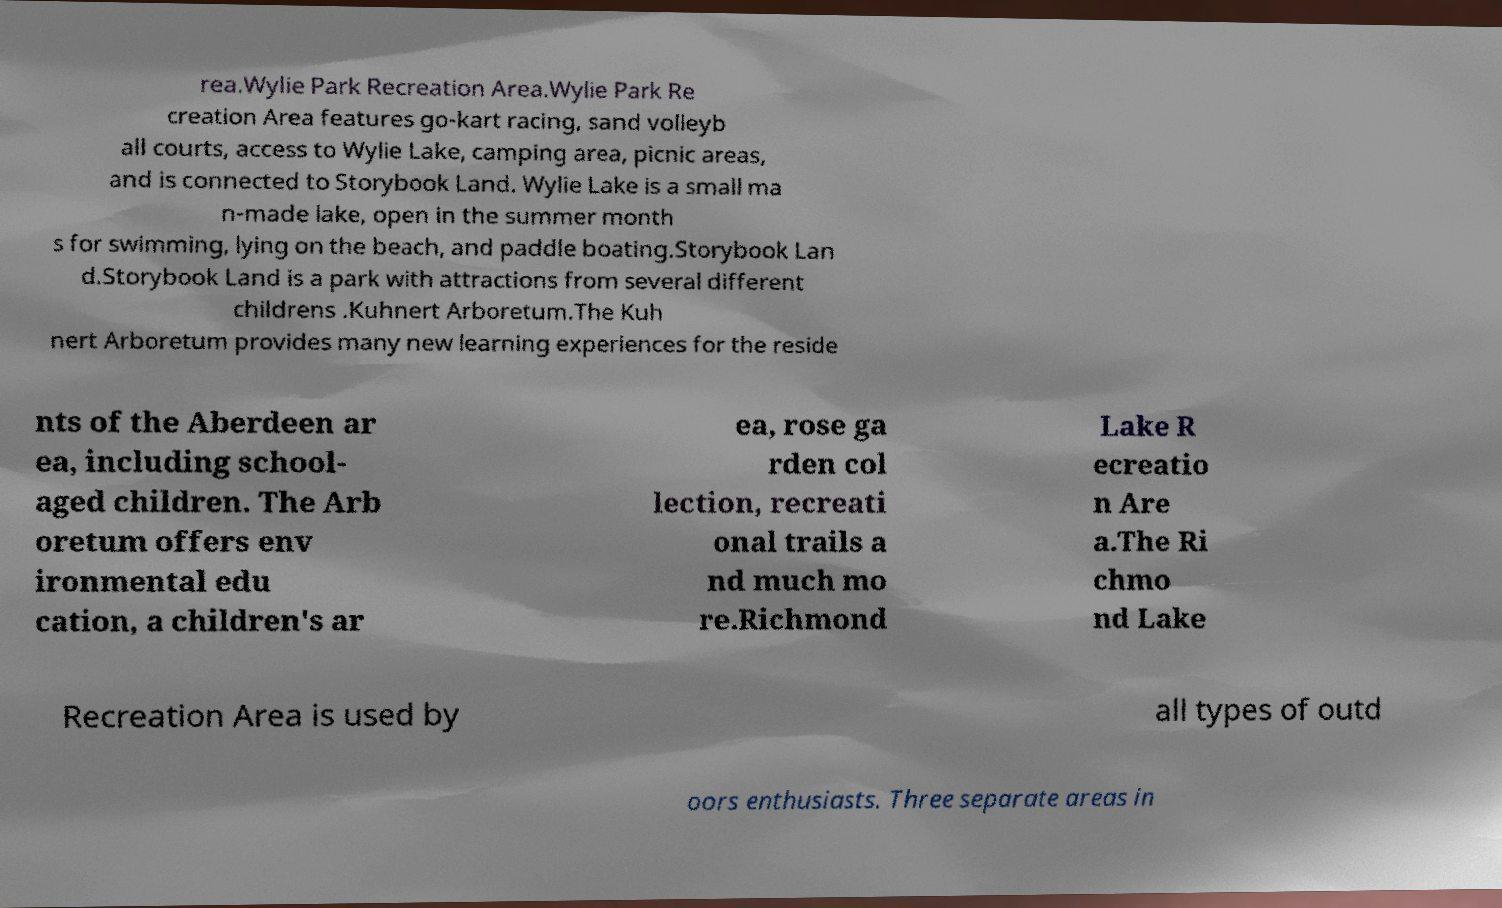Could you assist in decoding the text presented in this image and type it out clearly? rea.Wylie Park Recreation Area.Wylie Park Re creation Area features go-kart racing, sand volleyb all courts, access to Wylie Lake, camping area, picnic areas, and is connected to Storybook Land. Wylie Lake is a small ma n-made lake, open in the summer month s for swimming, lying on the beach, and paddle boating.Storybook Lan d.Storybook Land is a park with attractions from several different childrens .Kuhnert Arboretum.The Kuh nert Arboretum provides many new learning experiences for the reside nts of the Aberdeen ar ea, including school- aged children. The Arb oretum offers env ironmental edu cation, a children's ar ea, rose ga rden col lection, recreati onal trails a nd much mo re.Richmond Lake R ecreatio n Are a.The Ri chmo nd Lake Recreation Area is used by all types of outd oors enthusiasts. Three separate areas in 